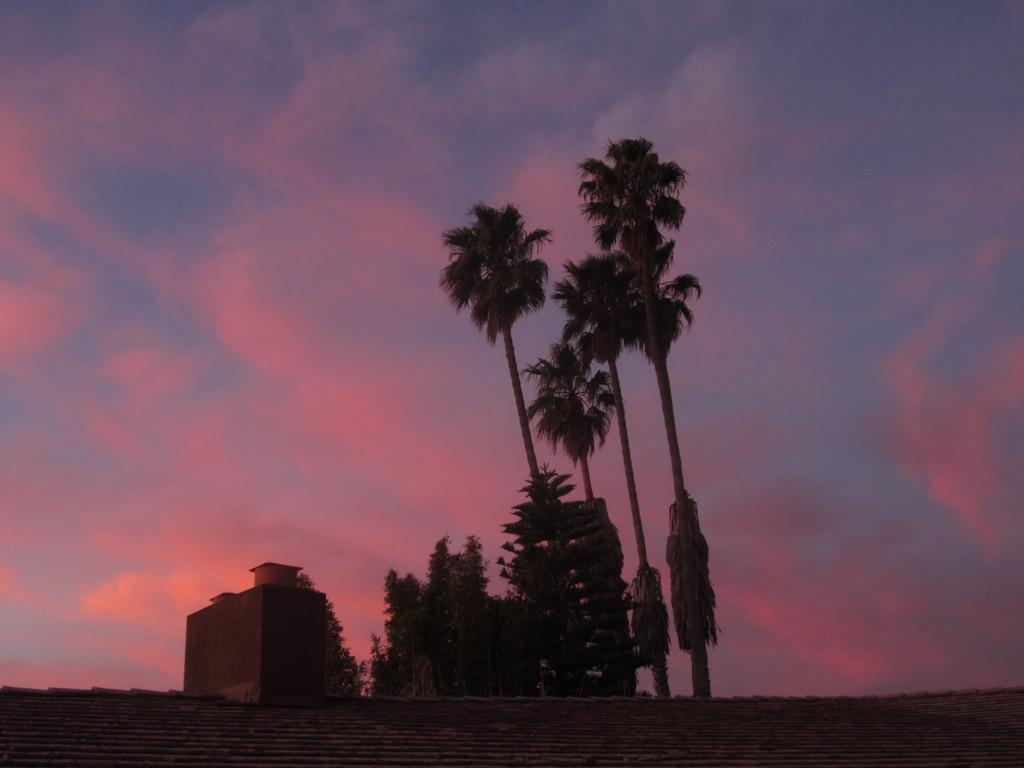What type of structure is visible in the image? There is a building in the image. What else can be seen in the image besides the building? There is a wall, trees, and the sky visible in the image. What is the condition of the sky in the image? The sky is visible in the background of the image, and clouds are present. What type of wrench is being used to fix the patch on the building in the image? There is no wrench or patch present in the image; it only features a building, wall, trees, and the sky. 